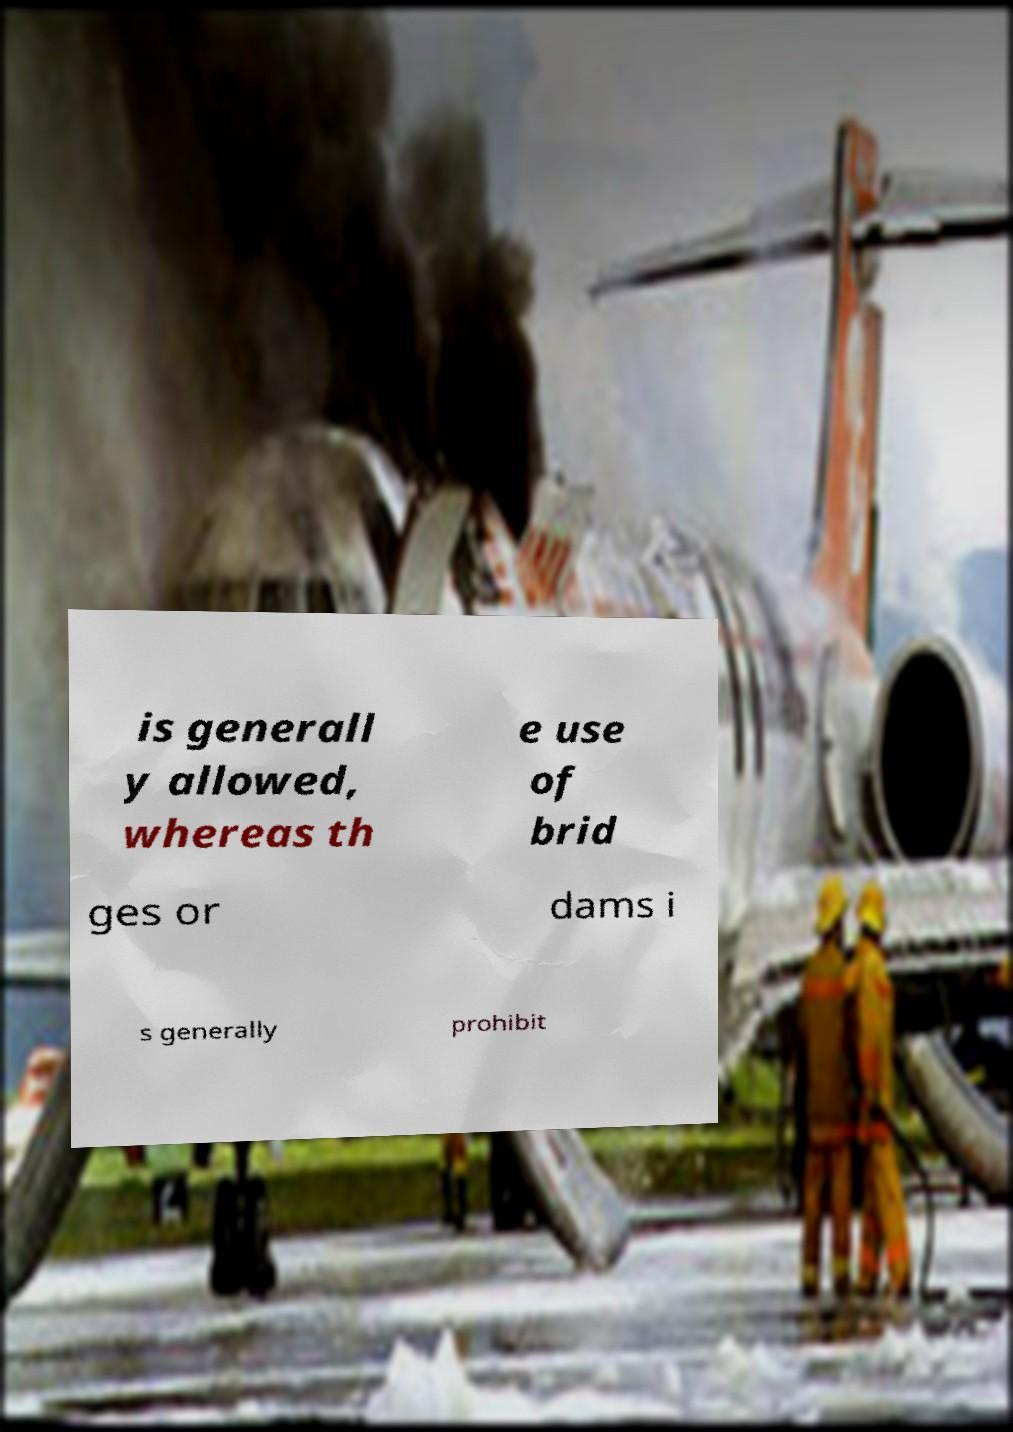Can you read and provide the text displayed in the image?This photo seems to have some interesting text. Can you extract and type it out for me? is generall y allowed, whereas th e use of brid ges or dams i s generally prohibit 